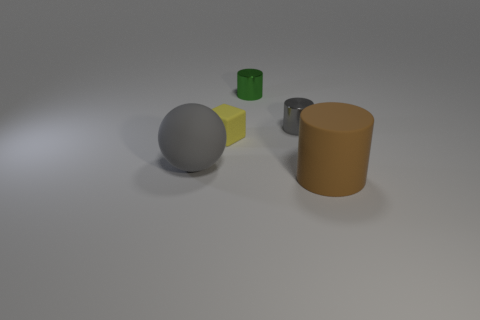What color is the shiny object that is the same size as the green metallic cylinder?
Your response must be concise. Gray. Is there a small green rubber thing of the same shape as the gray metallic object?
Your answer should be compact. No. What is the shape of the large brown matte thing?
Give a very brief answer. Cylinder. Are there more small cylinders to the left of the gray metallic cylinder than brown objects that are to the left of the small green metal thing?
Your answer should be very brief. Yes. What number of other things are the same size as the rubber sphere?
Offer a very short reply. 1. The object that is in front of the tiny yellow rubber object and on the left side of the matte cylinder is made of what material?
Offer a terse response. Rubber. What is the material of the other large thing that is the same shape as the green metal thing?
Offer a terse response. Rubber. There is a large matte object that is right of the gray thing that is in front of the yellow matte thing; what number of green objects are left of it?
Provide a short and direct response. 1. Is there any other thing of the same color as the ball?
Provide a succinct answer. Yes. How many things are both to the right of the small green metallic object and behind the brown thing?
Offer a very short reply. 1. 